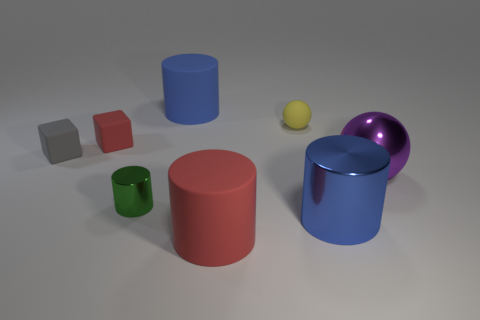Is the cylinder that is right of the small sphere made of the same material as the tiny green object?
Ensure brevity in your answer.  Yes. What size is the metal thing that is in front of the purple metal ball and on the right side of the tiny cylinder?
Your answer should be very brief. Large. There is a red object on the left side of the tiny cylinder; what is its size?
Give a very brief answer. Small. The large matte object that is behind the shiny cylinder that is left of the big blue cylinder behind the gray matte thing is what shape?
Make the answer very short. Cylinder. How many other things are there of the same shape as the tiny gray matte object?
Offer a terse response. 1. How many metal objects are blue objects or large red cylinders?
Offer a terse response. 1. There is a blue object to the right of the big rubber thing behind the big purple metallic thing; what is it made of?
Offer a terse response. Metal. Is the number of purple objects behind the small yellow rubber thing greater than the number of tiny matte cubes?
Ensure brevity in your answer.  No. Is there a blue cylinder that has the same material as the purple ball?
Ensure brevity in your answer.  Yes. Does the shiny thing that is on the left side of the small ball have the same shape as the gray object?
Keep it short and to the point. No. 